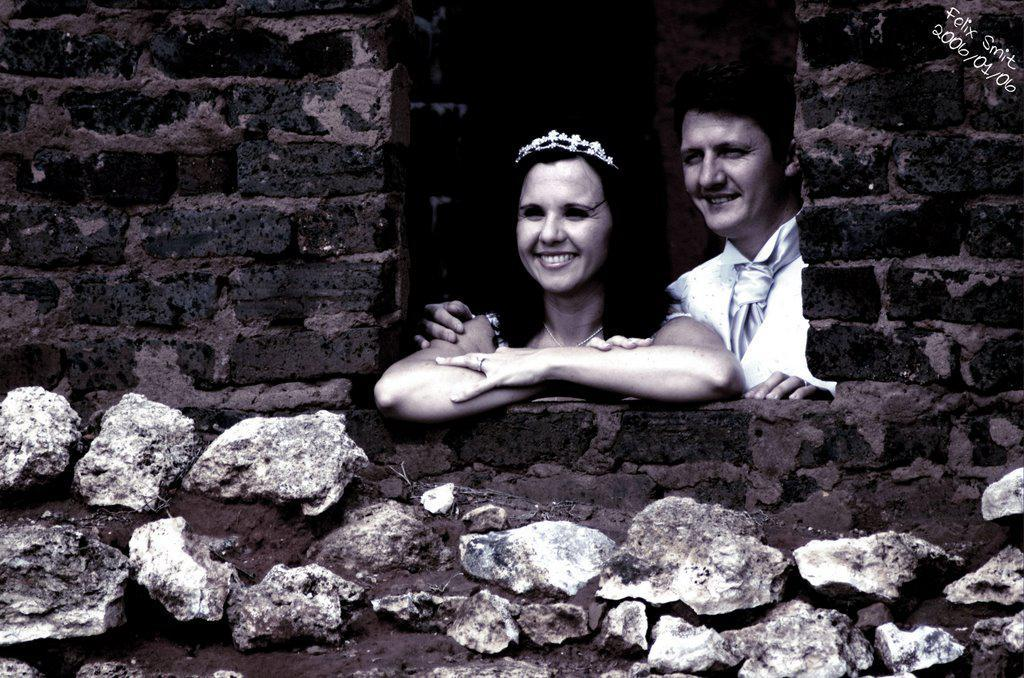How many people are in the image? There are two people in the image. Where are the people located? The people are standing inside a building. What is the facial expression of the people in the image? The people are smiling. What information is present in the top right of the image? There is some text and a date in the top right of the image. Can you see a bridge in the image? There is no bridge present in the image. What phase is the moon in the image? The image does not show the moon, so it is not possible to determine its phase. 